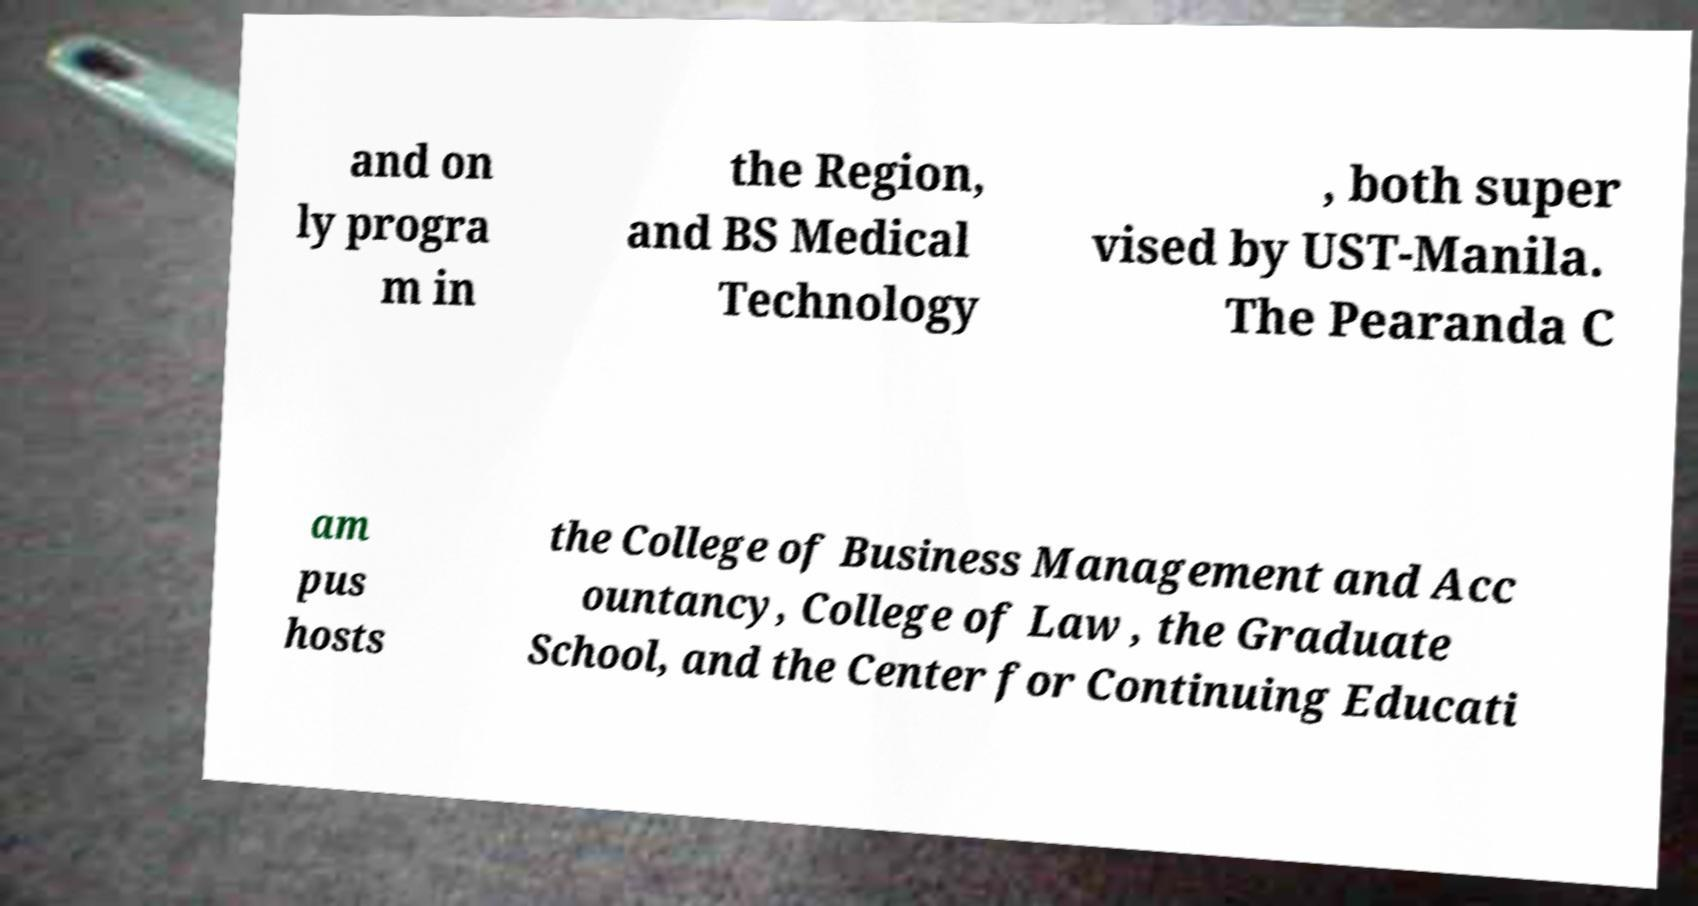Could you assist in decoding the text presented in this image and type it out clearly? and on ly progra m in the Region, and BS Medical Technology , both super vised by UST-Manila. The Pearanda C am pus hosts the College of Business Management and Acc ountancy, College of Law , the Graduate School, and the Center for Continuing Educati 